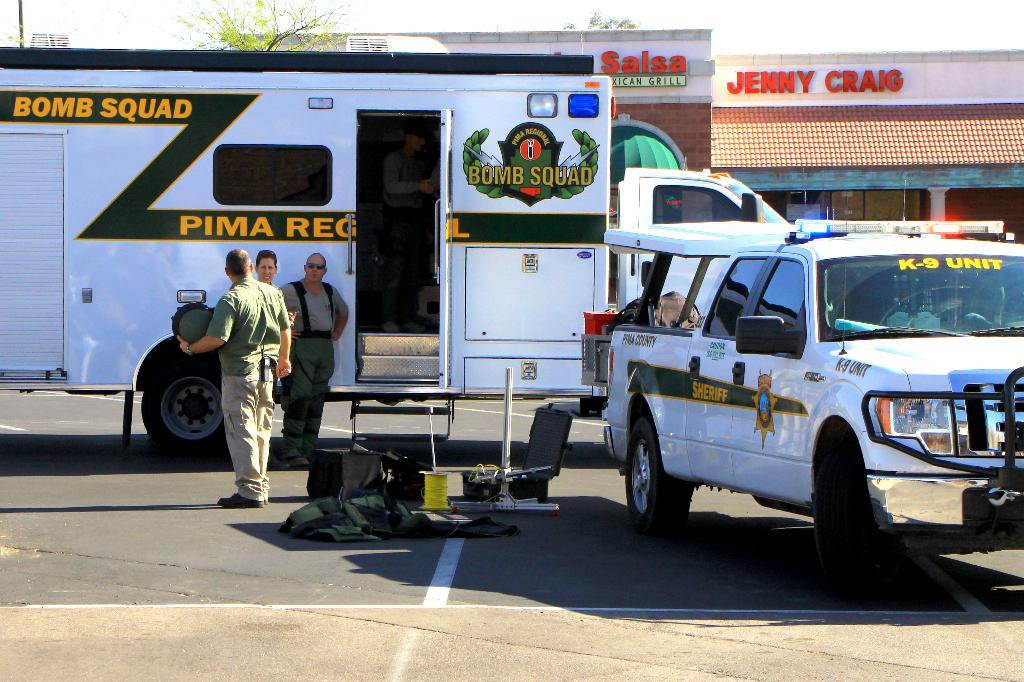What is the main subject in the center of the image? There is a truck in the center of the image. Can you describe the person in the image? There is a person standing on the road. What other vehicle is visible in the image? There is a car on the right side of the image. What can be seen in the background of the image? There is a house in the background of the image. What type of seed is being planted by the hen in the image? There is no hen or seed present in the image. What kind of pie is being served to the person standing on the road? There is no pie present in the image. 